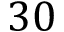Convert formula to latex. <formula><loc_0><loc_0><loc_500><loc_500>3 0</formula> 